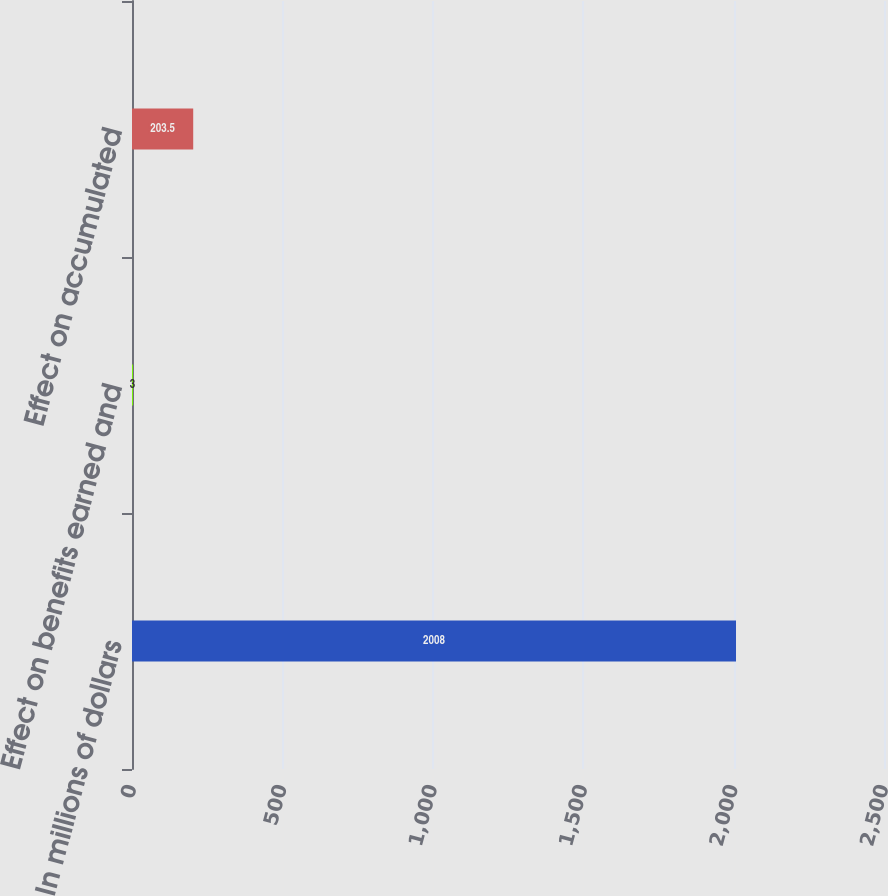Convert chart. <chart><loc_0><loc_0><loc_500><loc_500><bar_chart><fcel>In millions of dollars<fcel>Effect on benefits earned and<fcel>Effect on accumulated<nl><fcel>2008<fcel>3<fcel>203.5<nl></chart> 